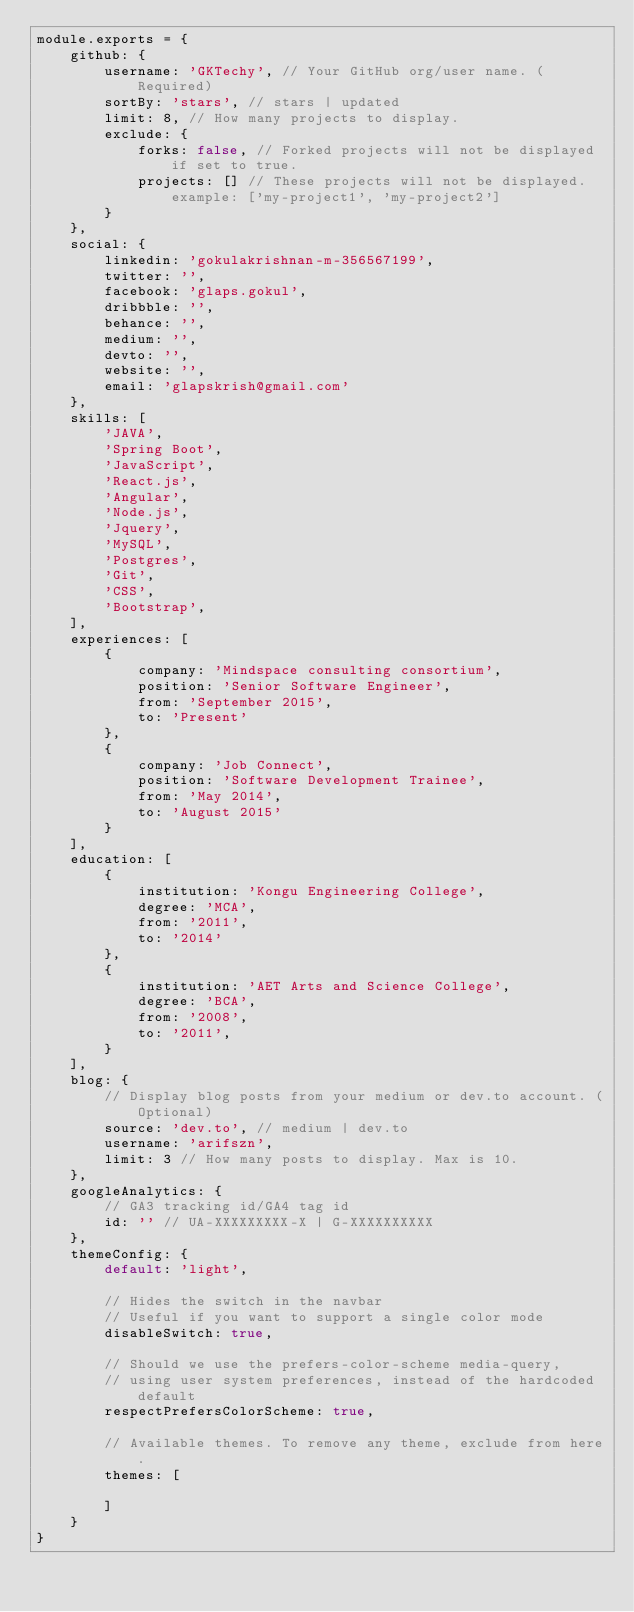<code> <loc_0><loc_0><loc_500><loc_500><_JavaScript_>module.exports = {
    github: {
        username: 'GKTechy', // Your GitHub org/user name. (Required)
        sortBy: 'stars', // stars | updated
        limit: 8, // How many projects to display.
        exclude: {
            forks: false, // Forked projects will not be displayed if set to true.
            projects: [] // These projects will not be displayed. example: ['my-project1', 'my-project2']
        }
    },
    social: {
        linkedin: 'gokulakrishnan-m-356567199',
        twitter: '',
        facebook: 'glaps.gokul',
        dribbble: '',
        behance: '',
        medium: '',
        devto: '',
        website: '',
        email: 'glapskrish@gmail.com'
    },
    skills: [
        'JAVA',
        'Spring Boot',
        'JavaScript',
        'React.js',
        'Angular',
        'Node.js',
        'Jquery',
        'MySQL',
        'Postgres',
        'Git',
        'CSS',
        'Bootstrap',
    ],
    experiences: [
        { 
            company: 'Mindspace consulting consortium',
            position: 'Senior Software Engineer',
            from: 'September 2015',
            to: 'Present'
        },
        { 
            company: 'Job Connect',
            position: 'Software Development Trainee',
            from: 'May 2014',
            to: 'August 2015'
        }
    ],
    education: [
        { 
            institution: 'Kongu Engineering College',
            degree: 'MCA',
            from: '2011',
            to: '2014'
        },
        { 
            institution: 'AET Arts and Science College',
            degree: 'BCA',
            from: '2008',
            to: '2011',
        }
    ],
    blog: {
        // Display blog posts from your medium or dev.to account. (Optional)
        source: 'dev.to', // medium | dev.to
        username: 'arifszn',
        limit: 3 // How many posts to display. Max is 10.
    },
    googleAnalytics: {
        // GA3 tracking id/GA4 tag id
        id: '' // UA-XXXXXXXXX-X | G-XXXXXXXXXX
    },
    themeConfig: {
        default: 'light',

        // Hides the switch in the navbar
        // Useful if you want to support a single color mode
        disableSwitch: true,

        // Should we use the prefers-color-scheme media-query,
        // using user system preferences, instead of the hardcoded default
        respectPrefersColorScheme: true,

        // Available themes. To remove any theme, exclude from here.
        themes: [
           
        ]
    }
}</code> 